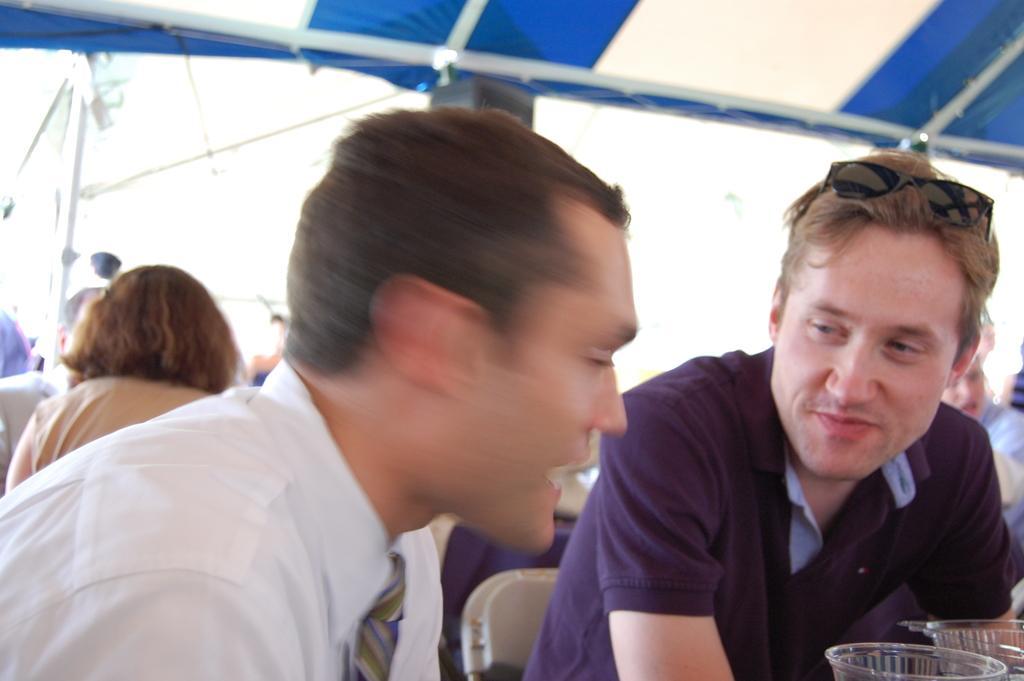Please provide a concise description of this image. In this image, we can see persons wearing clothes. There are glasses in the bottom right of the image. There is a tent at the top of the image. 